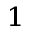Convert formula to latex. <formula><loc_0><loc_0><loc_500><loc_500>_ { 1 }</formula> 